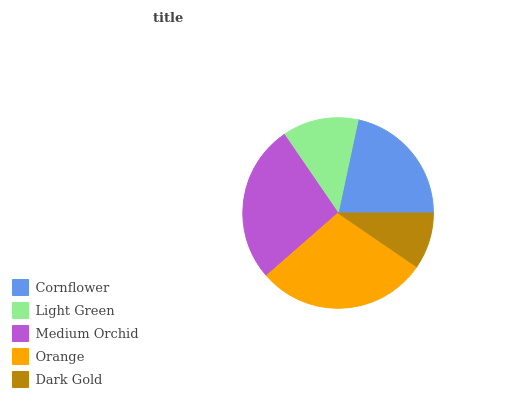Is Dark Gold the minimum?
Answer yes or no. Yes. Is Orange the maximum?
Answer yes or no. Yes. Is Light Green the minimum?
Answer yes or no. No. Is Light Green the maximum?
Answer yes or no. No. Is Cornflower greater than Light Green?
Answer yes or no. Yes. Is Light Green less than Cornflower?
Answer yes or no. Yes. Is Light Green greater than Cornflower?
Answer yes or no. No. Is Cornflower less than Light Green?
Answer yes or no. No. Is Cornflower the high median?
Answer yes or no. Yes. Is Cornflower the low median?
Answer yes or no. Yes. Is Dark Gold the high median?
Answer yes or no. No. Is Dark Gold the low median?
Answer yes or no. No. 